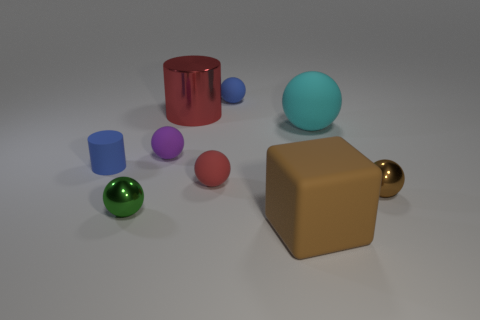Are the blue ball and the object to the left of the green sphere made of the same material?
Your answer should be compact. Yes. Are there more red cylinders that are right of the tiny cylinder than small gray things?
Give a very brief answer. Yes. The small object that is the same color as the big metal thing is what shape?
Your answer should be compact. Sphere. Are there any big cyan spheres made of the same material as the tiny purple ball?
Give a very brief answer. Yes. Does the brown thing behind the brown matte block have the same material as the large object in front of the tiny green object?
Your answer should be very brief. No. Are there an equal number of big cylinders right of the red shiny object and brown spheres that are in front of the large block?
Make the answer very short. Yes. There is a cylinder that is the same size as the brown rubber thing; what color is it?
Make the answer very short. Red. Are there any things that have the same color as the big cylinder?
Your answer should be compact. Yes. What number of objects are matte spheres on the right side of the large cube or big matte balls?
Your response must be concise. 1. How many other things are there of the same size as the brown block?
Provide a short and direct response. 2. 